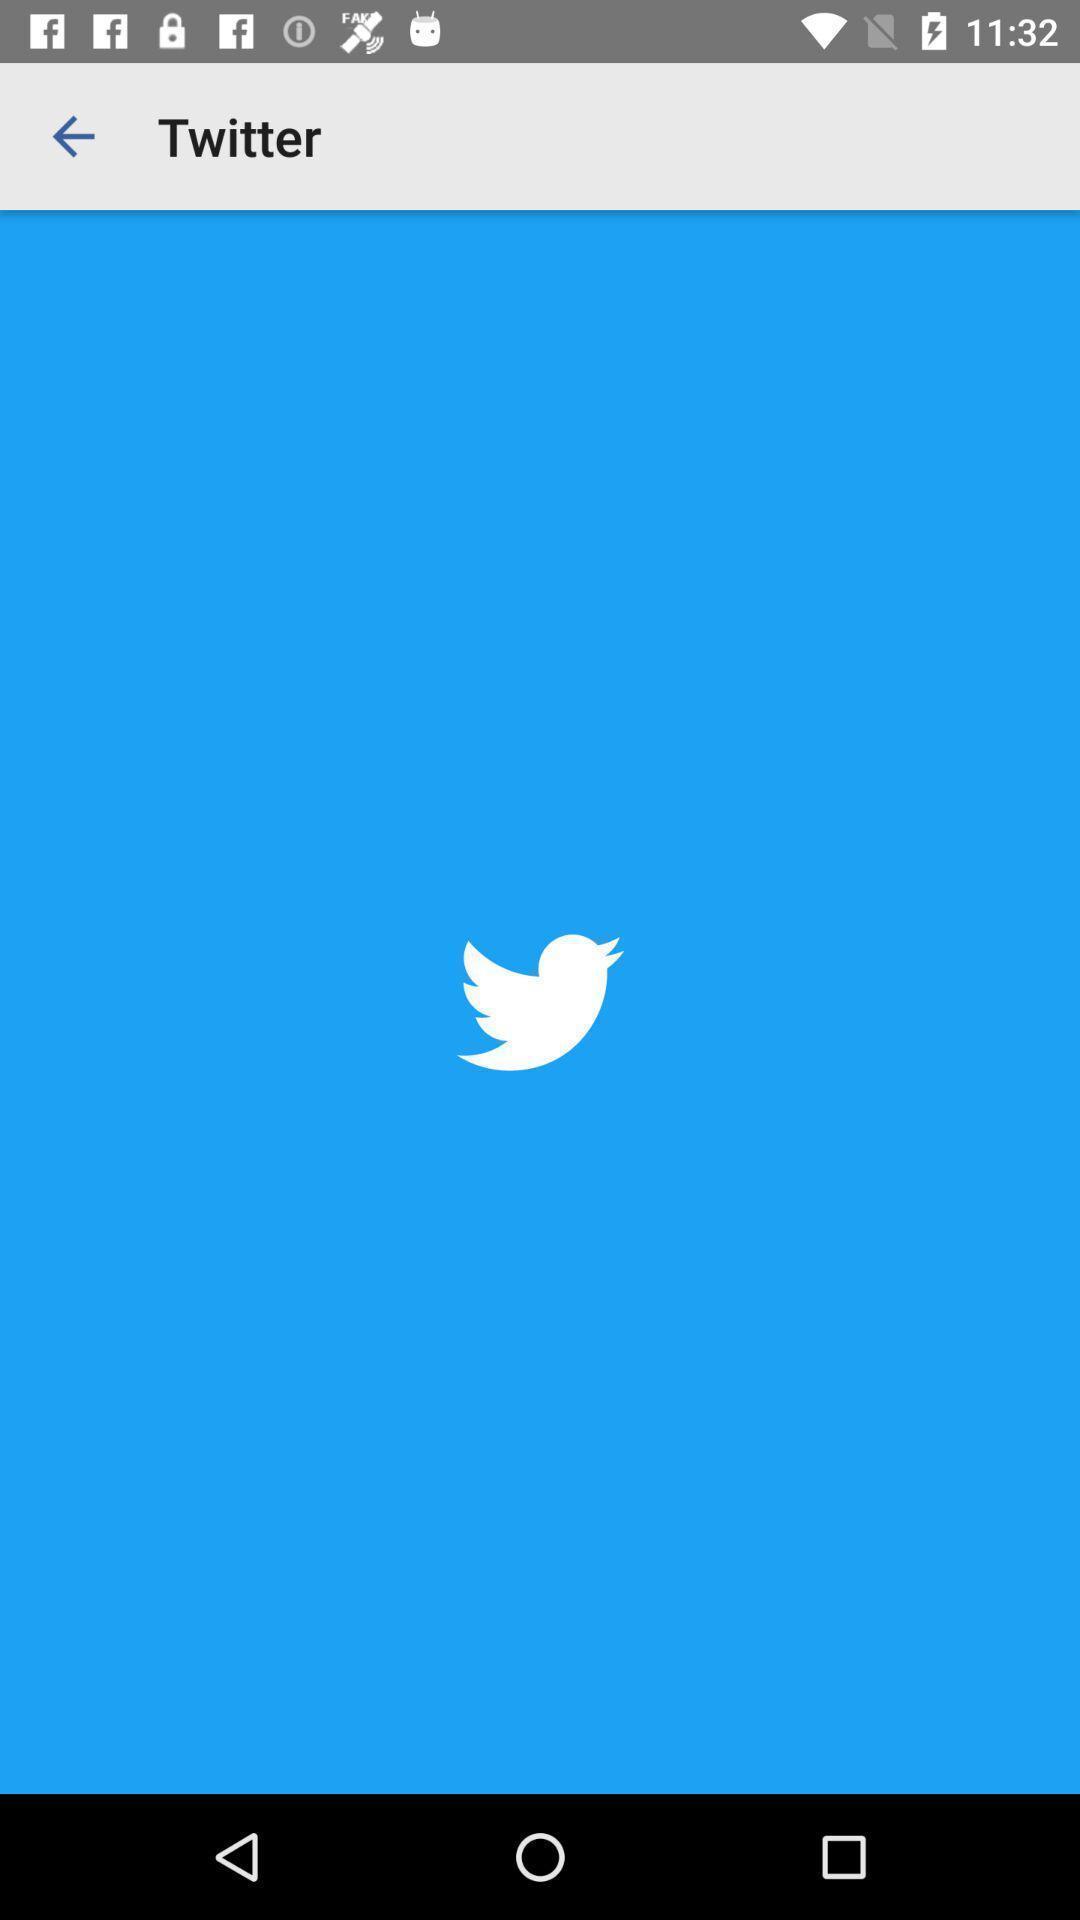Provide a textual representation of this image. Screen displaying page of an social application. 